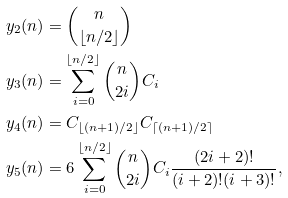<formula> <loc_0><loc_0><loc_500><loc_500>y _ { 2 } ( n ) & = { n \choose \lfloor n / 2 \rfloor } \\ y _ { 3 } ( n ) & = \sum _ { i = 0 } ^ { \lfloor n / 2 \rfloor } { n \choose 2 i } C _ { i } \\ y _ { 4 } ( n ) & = C _ { \lfloor ( n + 1 ) / 2 \rfloor } C _ { \lceil ( n + 1 ) / 2 \rceil } \\ y _ { 5 } ( n ) & = 6 \sum _ { i = 0 } ^ { \lfloor n / 2 \rfloor } { n \choose 2 i } C _ { i } \frac { ( 2 i + 2 ) ! } { ( i + 2 ) ! ( i + 3 ) ! } ,</formula> 